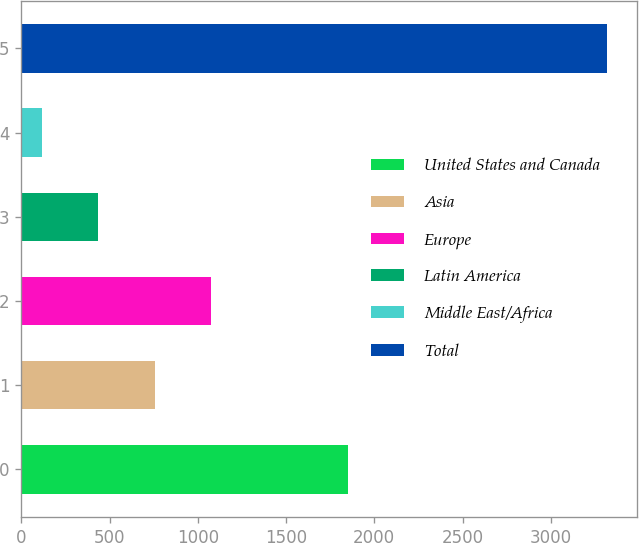<chart> <loc_0><loc_0><loc_500><loc_500><bar_chart><fcel>United States and Canada<fcel>Asia<fcel>Europe<fcel>Latin America<fcel>Middle East/Africa<fcel>Total<nl><fcel>1852<fcel>756.2<fcel>1076.8<fcel>435.6<fcel>115<fcel>3321<nl></chart> 